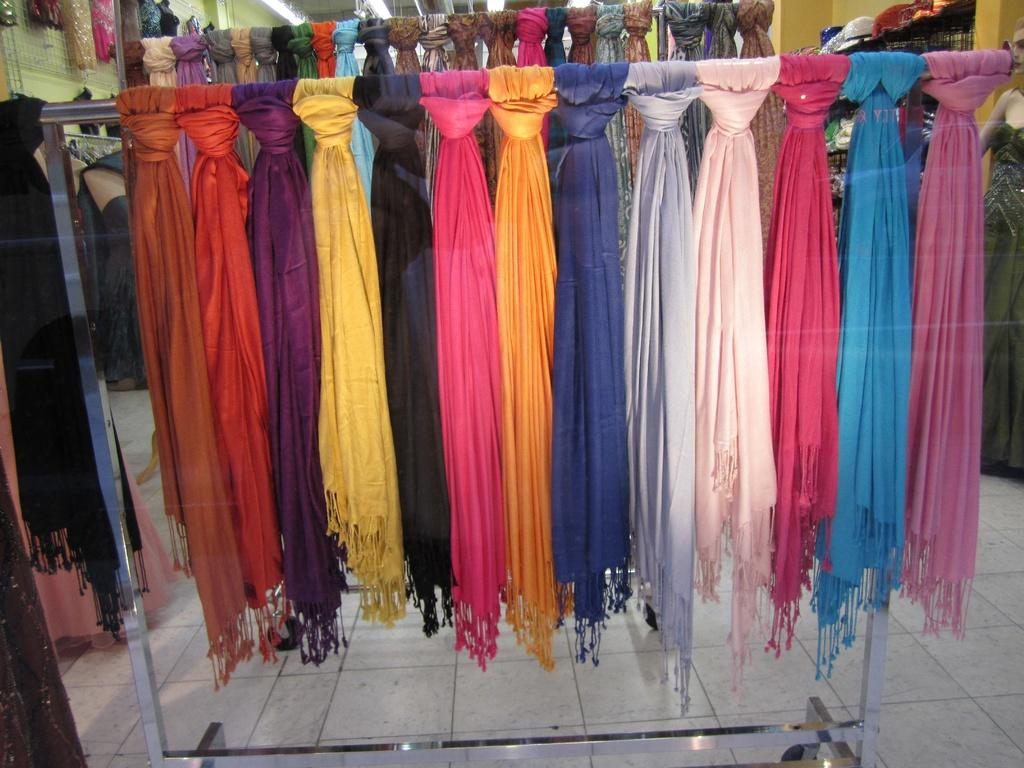What items are displayed on the stands in the image? There are colorful scarves hanging on display stands in the image. Can you describe the person on the right side of the image? The person is standing and wearing clothes. How many kittens are sitting on top of the cake in the image? There is no cake or kittens present in the image. 